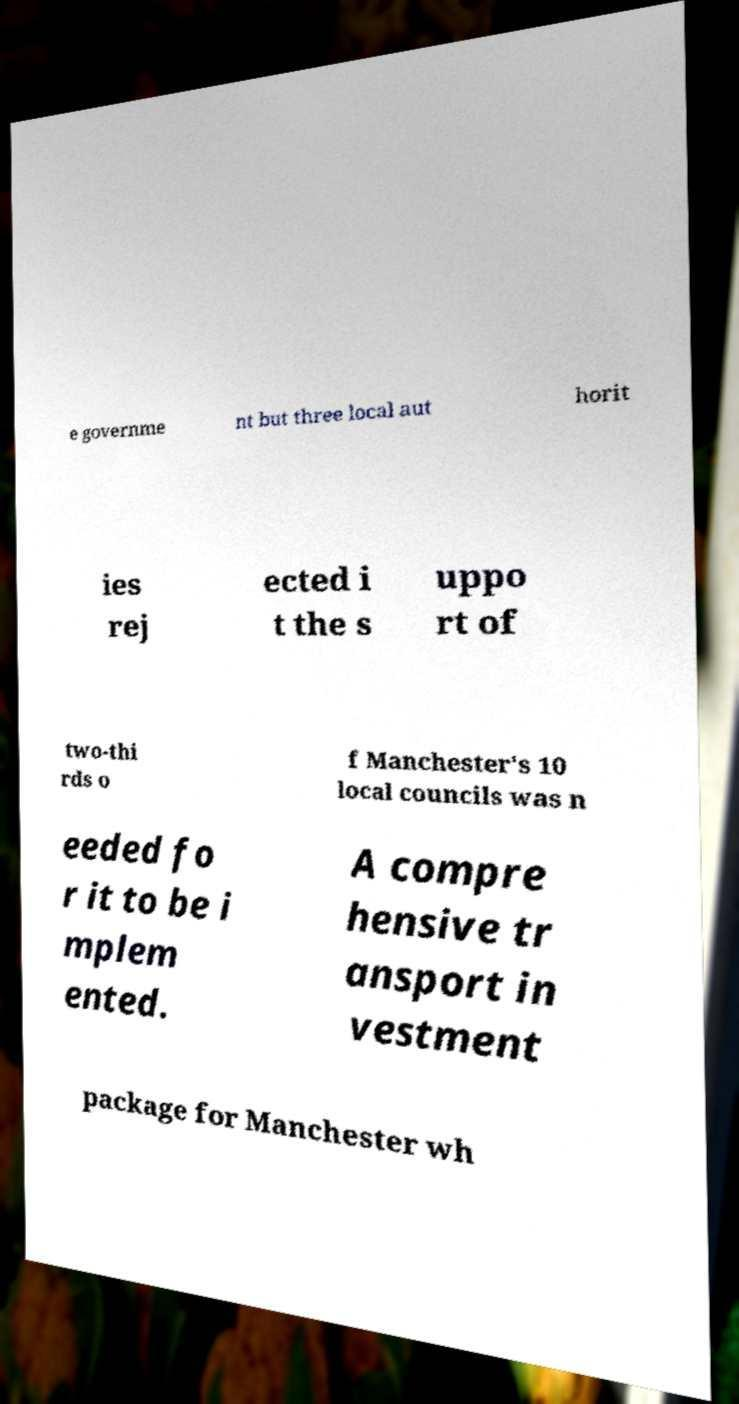Could you extract and type out the text from this image? e governme nt but three local aut horit ies rej ected i t the s uppo rt of two-thi rds o f Manchester's 10 local councils was n eeded fo r it to be i mplem ented. A compre hensive tr ansport in vestment package for Manchester wh 